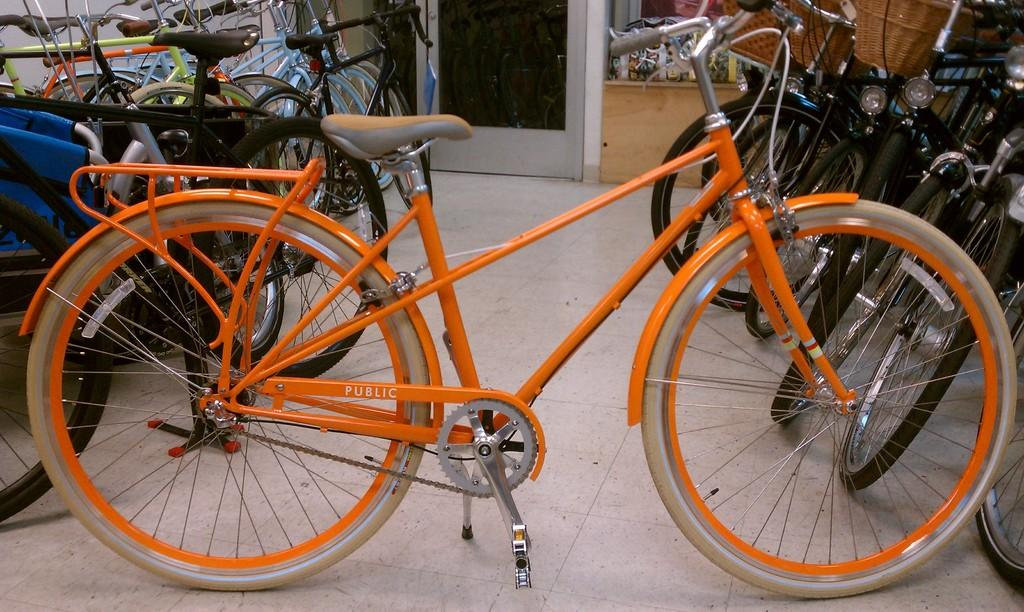What type of vehicles are in the image? There are bicycles in the image. How are the bicycles positioned in the image? The bicycles are parked on the floor. What can be seen in the background of the image? There is a door visible in the background of the image. What type of butter is being used to grease the bicycle chains in the image? There is no butter or any indication of bicycle chain maintenance in the image. 